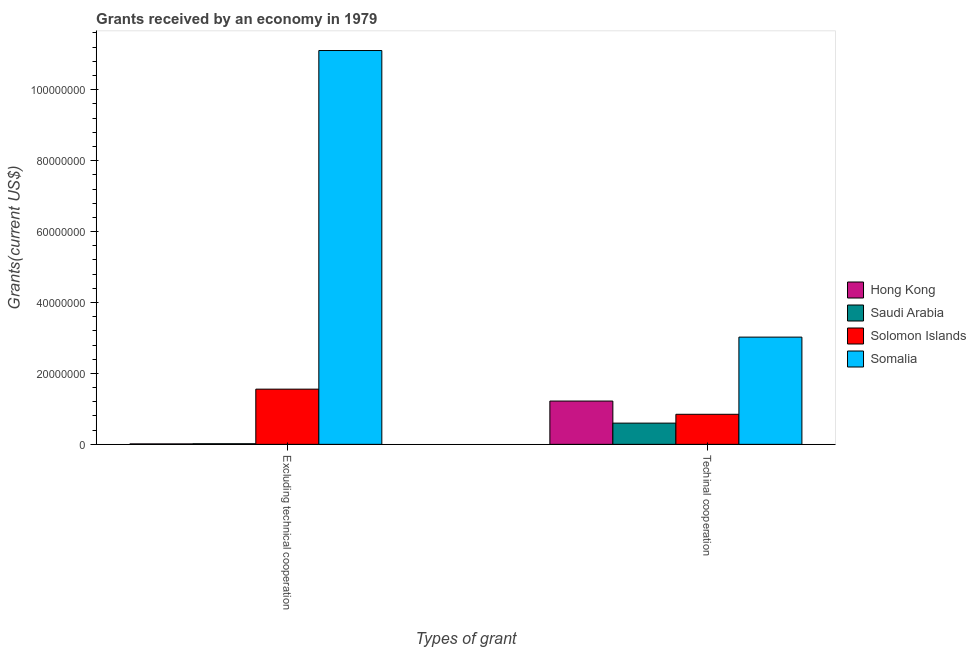What is the label of the 1st group of bars from the left?
Provide a succinct answer. Excluding technical cooperation. What is the amount of grants received(including technical cooperation) in Saudi Arabia?
Offer a very short reply. 5.99e+06. Across all countries, what is the maximum amount of grants received(excluding technical cooperation)?
Keep it short and to the point. 1.11e+08. Across all countries, what is the minimum amount of grants received(including technical cooperation)?
Give a very brief answer. 5.99e+06. In which country was the amount of grants received(excluding technical cooperation) maximum?
Your response must be concise. Somalia. In which country was the amount of grants received(excluding technical cooperation) minimum?
Offer a very short reply. Hong Kong. What is the total amount of grants received(including technical cooperation) in the graph?
Offer a terse response. 5.69e+07. What is the difference between the amount of grants received(excluding technical cooperation) in Solomon Islands and that in Hong Kong?
Your answer should be very brief. 1.54e+07. What is the difference between the amount of grants received(excluding technical cooperation) in Hong Kong and the amount of grants received(including technical cooperation) in Somalia?
Your response must be concise. -3.01e+07. What is the average amount of grants received(excluding technical cooperation) per country?
Provide a short and direct response. 3.17e+07. What is the difference between the amount of grants received(excluding technical cooperation) and amount of grants received(including technical cooperation) in Solomon Islands?
Give a very brief answer. 7.09e+06. In how many countries, is the amount of grants received(including technical cooperation) greater than 4000000 US$?
Give a very brief answer. 4. What is the ratio of the amount of grants received(including technical cooperation) in Hong Kong to that in Saudi Arabia?
Make the answer very short. 2.04. In how many countries, is the amount of grants received(excluding technical cooperation) greater than the average amount of grants received(excluding technical cooperation) taken over all countries?
Your answer should be compact. 1. What does the 3rd bar from the left in Excluding technical cooperation represents?
Your answer should be compact. Solomon Islands. What does the 4th bar from the right in Excluding technical cooperation represents?
Offer a very short reply. Hong Kong. How many bars are there?
Your answer should be compact. 8. Are all the bars in the graph horizontal?
Offer a terse response. No. How many legend labels are there?
Your response must be concise. 4. How are the legend labels stacked?
Offer a very short reply. Vertical. What is the title of the graph?
Your answer should be compact. Grants received by an economy in 1979. What is the label or title of the X-axis?
Provide a succinct answer. Types of grant. What is the label or title of the Y-axis?
Ensure brevity in your answer.  Grants(current US$). What is the Grants(current US$) in Hong Kong in Excluding technical cooperation?
Offer a very short reply. 1.30e+05. What is the Grants(current US$) in Solomon Islands in Excluding technical cooperation?
Offer a terse response. 1.56e+07. What is the Grants(current US$) of Somalia in Excluding technical cooperation?
Your answer should be very brief. 1.11e+08. What is the Grants(current US$) of Hong Kong in Techinal cooperation?
Provide a short and direct response. 1.22e+07. What is the Grants(current US$) of Saudi Arabia in Techinal cooperation?
Offer a very short reply. 5.99e+06. What is the Grants(current US$) in Solomon Islands in Techinal cooperation?
Your response must be concise. 8.48e+06. What is the Grants(current US$) of Somalia in Techinal cooperation?
Provide a short and direct response. 3.02e+07. Across all Types of grant, what is the maximum Grants(current US$) in Hong Kong?
Your answer should be compact. 1.22e+07. Across all Types of grant, what is the maximum Grants(current US$) of Saudi Arabia?
Keep it short and to the point. 5.99e+06. Across all Types of grant, what is the maximum Grants(current US$) of Solomon Islands?
Offer a terse response. 1.56e+07. Across all Types of grant, what is the maximum Grants(current US$) in Somalia?
Your response must be concise. 1.11e+08. Across all Types of grant, what is the minimum Grants(current US$) of Hong Kong?
Provide a short and direct response. 1.30e+05. Across all Types of grant, what is the minimum Grants(current US$) of Solomon Islands?
Keep it short and to the point. 8.48e+06. Across all Types of grant, what is the minimum Grants(current US$) in Somalia?
Give a very brief answer. 3.02e+07. What is the total Grants(current US$) of Hong Kong in the graph?
Your answer should be compact. 1.23e+07. What is the total Grants(current US$) of Saudi Arabia in the graph?
Your answer should be very brief. 6.17e+06. What is the total Grants(current US$) in Solomon Islands in the graph?
Provide a short and direct response. 2.40e+07. What is the total Grants(current US$) of Somalia in the graph?
Provide a succinct answer. 1.41e+08. What is the difference between the Grants(current US$) of Hong Kong in Excluding technical cooperation and that in Techinal cooperation?
Your response must be concise. -1.21e+07. What is the difference between the Grants(current US$) in Saudi Arabia in Excluding technical cooperation and that in Techinal cooperation?
Keep it short and to the point. -5.81e+06. What is the difference between the Grants(current US$) of Solomon Islands in Excluding technical cooperation and that in Techinal cooperation?
Your answer should be compact. 7.09e+06. What is the difference between the Grants(current US$) in Somalia in Excluding technical cooperation and that in Techinal cooperation?
Your answer should be very brief. 8.08e+07. What is the difference between the Grants(current US$) in Hong Kong in Excluding technical cooperation and the Grants(current US$) in Saudi Arabia in Techinal cooperation?
Your answer should be very brief. -5.86e+06. What is the difference between the Grants(current US$) in Hong Kong in Excluding technical cooperation and the Grants(current US$) in Solomon Islands in Techinal cooperation?
Give a very brief answer. -8.35e+06. What is the difference between the Grants(current US$) of Hong Kong in Excluding technical cooperation and the Grants(current US$) of Somalia in Techinal cooperation?
Keep it short and to the point. -3.01e+07. What is the difference between the Grants(current US$) in Saudi Arabia in Excluding technical cooperation and the Grants(current US$) in Solomon Islands in Techinal cooperation?
Provide a succinct answer. -8.30e+06. What is the difference between the Grants(current US$) in Saudi Arabia in Excluding technical cooperation and the Grants(current US$) in Somalia in Techinal cooperation?
Keep it short and to the point. -3.01e+07. What is the difference between the Grants(current US$) in Solomon Islands in Excluding technical cooperation and the Grants(current US$) in Somalia in Techinal cooperation?
Ensure brevity in your answer.  -1.47e+07. What is the average Grants(current US$) of Hong Kong per Types of grant?
Provide a short and direct response. 6.17e+06. What is the average Grants(current US$) in Saudi Arabia per Types of grant?
Provide a succinct answer. 3.08e+06. What is the average Grants(current US$) in Solomon Islands per Types of grant?
Offer a terse response. 1.20e+07. What is the average Grants(current US$) in Somalia per Types of grant?
Your response must be concise. 7.06e+07. What is the difference between the Grants(current US$) of Hong Kong and Grants(current US$) of Saudi Arabia in Excluding technical cooperation?
Your response must be concise. -5.00e+04. What is the difference between the Grants(current US$) of Hong Kong and Grants(current US$) of Solomon Islands in Excluding technical cooperation?
Your answer should be very brief. -1.54e+07. What is the difference between the Grants(current US$) in Hong Kong and Grants(current US$) in Somalia in Excluding technical cooperation?
Your answer should be compact. -1.11e+08. What is the difference between the Grants(current US$) of Saudi Arabia and Grants(current US$) of Solomon Islands in Excluding technical cooperation?
Make the answer very short. -1.54e+07. What is the difference between the Grants(current US$) in Saudi Arabia and Grants(current US$) in Somalia in Excluding technical cooperation?
Provide a succinct answer. -1.11e+08. What is the difference between the Grants(current US$) in Solomon Islands and Grants(current US$) in Somalia in Excluding technical cooperation?
Your answer should be very brief. -9.55e+07. What is the difference between the Grants(current US$) in Hong Kong and Grants(current US$) in Saudi Arabia in Techinal cooperation?
Provide a succinct answer. 6.22e+06. What is the difference between the Grants(current US$) in Hong Kong and Grants(current US$) in Solomon Islands in Techinal cooperation?
Your response must be concise. 3.73e+06. What is the difference between the Grants(current US$) in Hong Kong and Grants(current US$) in Somalia in Techinal cooperation?
Provide a succinct answer. -1.80e+07. What is the difference between the Grants(current US$) of Saudi Arabia and Grants(current US$) of Solomon Islands in Techinal cooperation?
Offer a very short reply. -2.49e+06. What is the difference between the Grants(current US$) in Saudi Arabia and Grants(current US$) in Somalia in Techinal cooperation?
Make the answer very short. -2.42e+07. What is the difference between the Grants(current US$) of Solomon Islands and Grants(current US$) of Somalia in Techinal cooperation?
Your answer should be very brief. -2.18e+07. What is the ratio of the Grants(current US$) in Hong Kong in Excluding technical cooperation to that in Techinal cooperation?
Provide a succinct answer. 0.01. What is the ratio of the Grants(current US$) in Saudi Arabia in Excluding technical cooperation to that in Techinal cooperation?
Your answer should be very brief. 0.03. What is the ratio of the Grants(current US$) of Solomon Islands in Excluding technical cooperation to that in Techinal cooperation?
Your answer should be very brief. 1.84. What is the ratio of the Grants(current US$) in Somalia in Excluding technical cooperation to that in Techinal cooperation?
Provide a short and direct response. 3.67. What is the difference between the highest and the second highest Grants(current US$) of Hong Kong?
Provide a succinct answer. 1.21e+07. What is the difference between the highest and the second highest Grants(current US$) of Saudi Arabia?
Your answer should be very brief. 5.81e+06. What is the difference between the highest and the second highest Grants(current US$) in Solomon Islands?
Offer a terse response. 7.09e+06. What is the difference between the highest and the second highest Grants(current US$) of Somalia?
Make the answer very short. 8.08e+07. What is the difference between the highest and the lowest Grants(current US$) of Hong Kong?
Offer a terse response. 1.21e+07. What is the difference between the highest and the lowest Grants(current US$) in Saudi Arabia?
Provide a short and direct response. 5.81e+06. What is the difference between the highest and the lowest Grants(current US$) in Solomon Islands?
Provide a succinct answer. 7.09e+06. What is the difference between the highest and the lowest Grants(current US$) of Somalia?
Your response must be concise. 8.08e+07. 